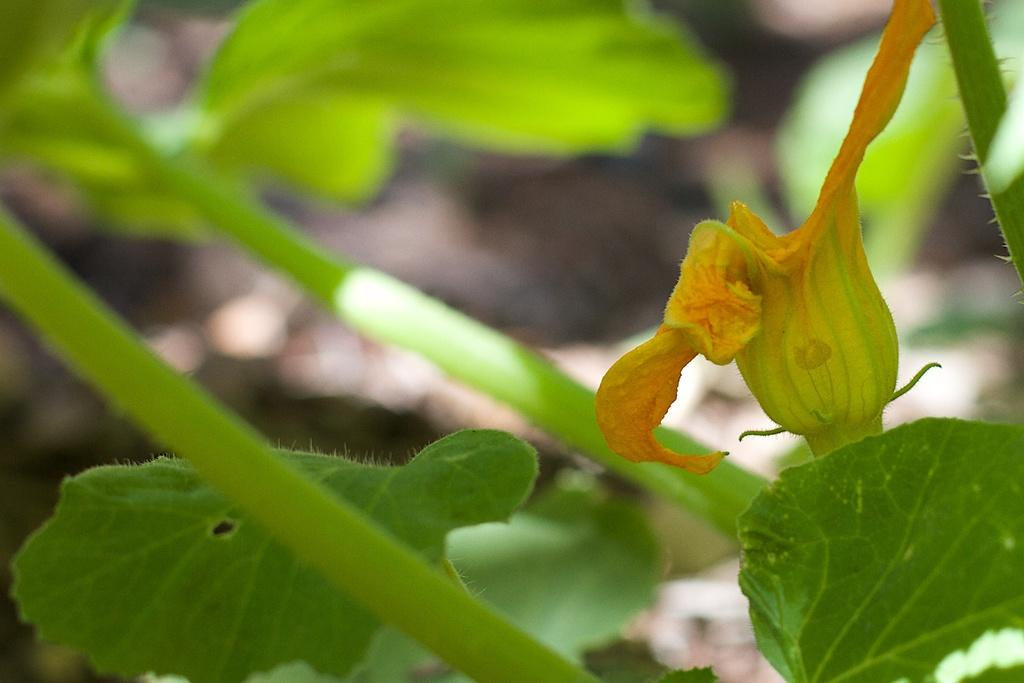What type of vegetation can be seen in the image? There are green leaves in the image. What color is the flower in the image? There is a yellow flower in the image. Where is the crayon located in the image? There is no crayon present in the image. What type of transportation can be seen in the image? There is no transportation present in the image. 